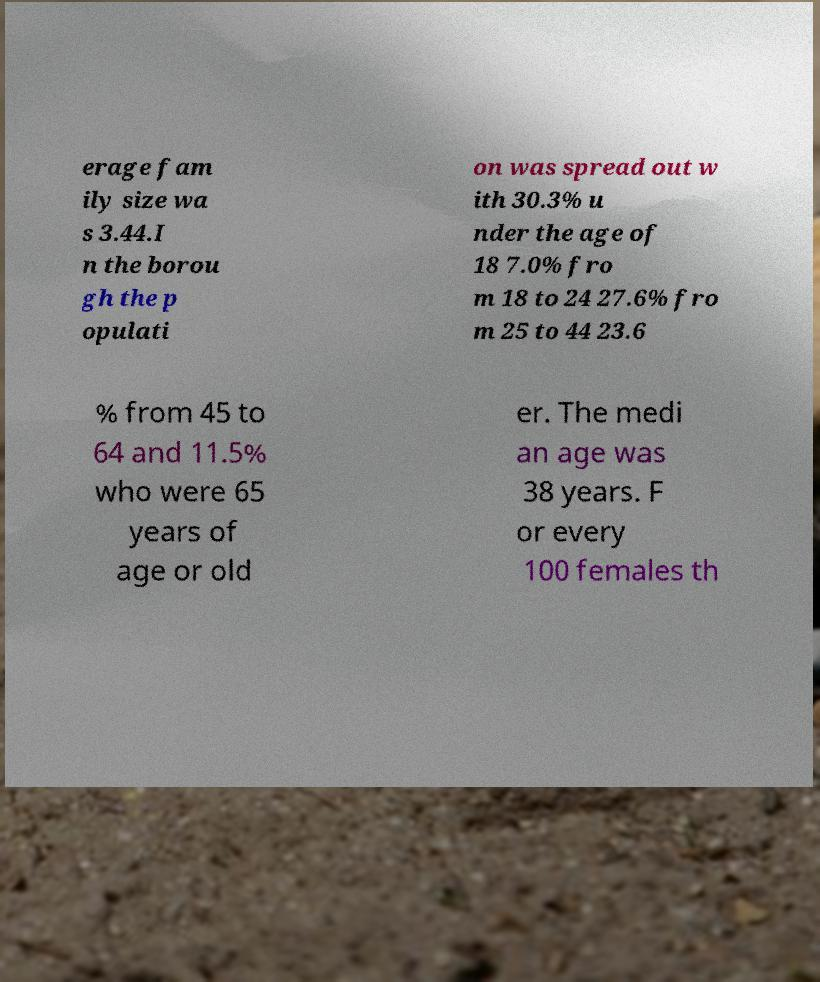For documentation purposes, I need the text within this image transcribed. Could you provide that? erage fam ily size wa s 3.44.I n the borou gh the p opulati on was spread out w ith 30.3% u nder the age of 18 7.0% fro m 18 to 24 27.6% fro m 25 to 44 23.6 % from 45 to 64 and 11.5% who were 65 years of age or old er. The medi an age was 38 years. F or every 100 females th 